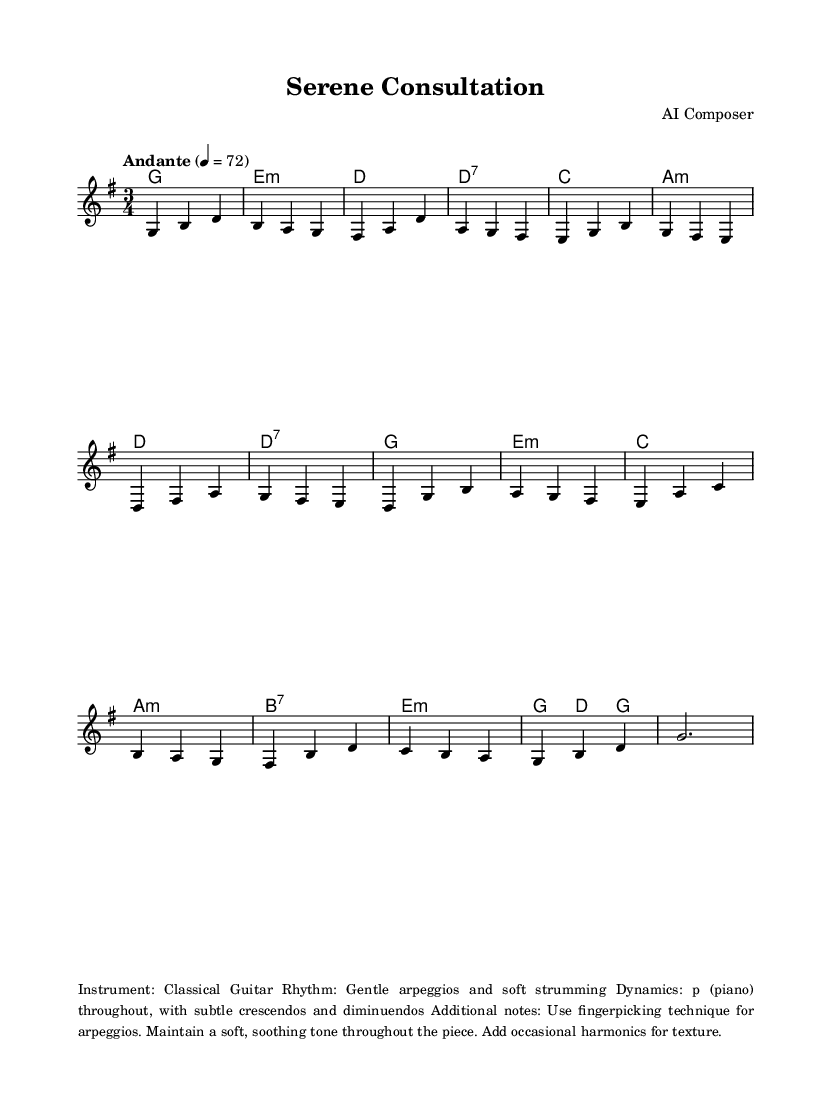What is the key signature of this music? The key signature is G major, which has one sharp (F#). This is determined by looking at the beginning of the staff in the sheet music where the key signature is notated.
Answer: G major What is the time signature of this music? The time signature displayed is 3/4, meaning there are three beats in each measure and a quarter note gets one beat. It is indicated by the time signature symbol at the beginning of the staff.
Answer: 3/4 What is the tempo marking for this piece? The tempo is marked as "Andante," which indicates a moderate pace, typically around 76-108 beats per minute. The specific BPM is provided as 4=72, meaning the quarter note is set at 72 beats per minute.
Answer: Andante How many measures does the piece contain? By counting the individual measures in the sheet music, there are a total of 16 measures. This includes every set of vertical lines that separates one measure from another.
Answer: 16 What is the dynamic marking throughout the piece? The dynamic marking indicates a soft volume, referred to as 'p' (piano), which means to play softly. This dynamic is usually indicated at the beginning of the piece and maintained through it.
Answer: p Describe the rhythm style used in this piece. The rhythm is characterized by gentle arpeggios and soft strumming throughout the piece. This is evident in the melodic phrasing and the chord progressions that suggest a flowing, gentle rhythmic style.
Answer: Gentle arpeggios and soft strumming What technique is suggested for playing the arpeggios? The piece suggests using fingerpicking technique for the arpeggios, which involves plucking individual strings with the fingers instead of using a pick, thus creating a softer sound. This is mentioned in the additional notes section of the markup.
Answer: Fingerpicking technique 